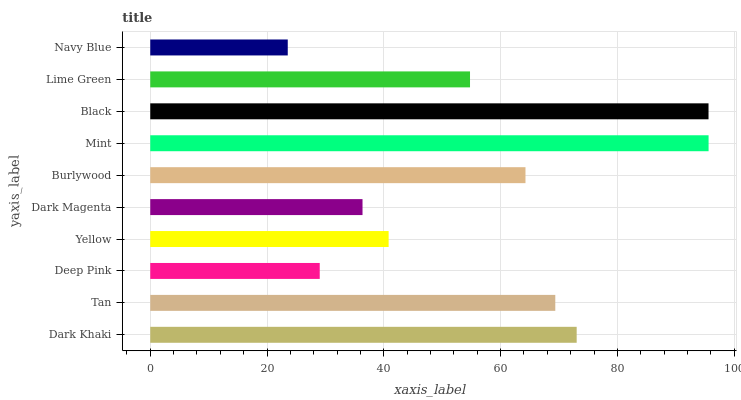Is Navy Blue the minimum?
Answer yes or no. Yes. Is Mint the maximum?
Answer yes or no. Yes. Is Tan the minimum?
Answer yes or no. No. Is Tan the maximum?
Answer yes or no. No. Is Dark Khaki greater than Tan?
Answer yes or no. Yes. Is Tan less than Dark Khaki?
Answer yes or no. Yes. Is Tan greater than Dark Khaki?
Answer yes or no. No. Is Dark Khaki less than Tan?
Answer yes or no. No. Is Burlywood the high median?
Answer yes or no. Yes. Is Lime Green the low median?
Answer yes or no. Yes. Is Dark Khaki the high median?
Answer yes or no. No. Is Yellow the low median?
Answer yes or no. No. 